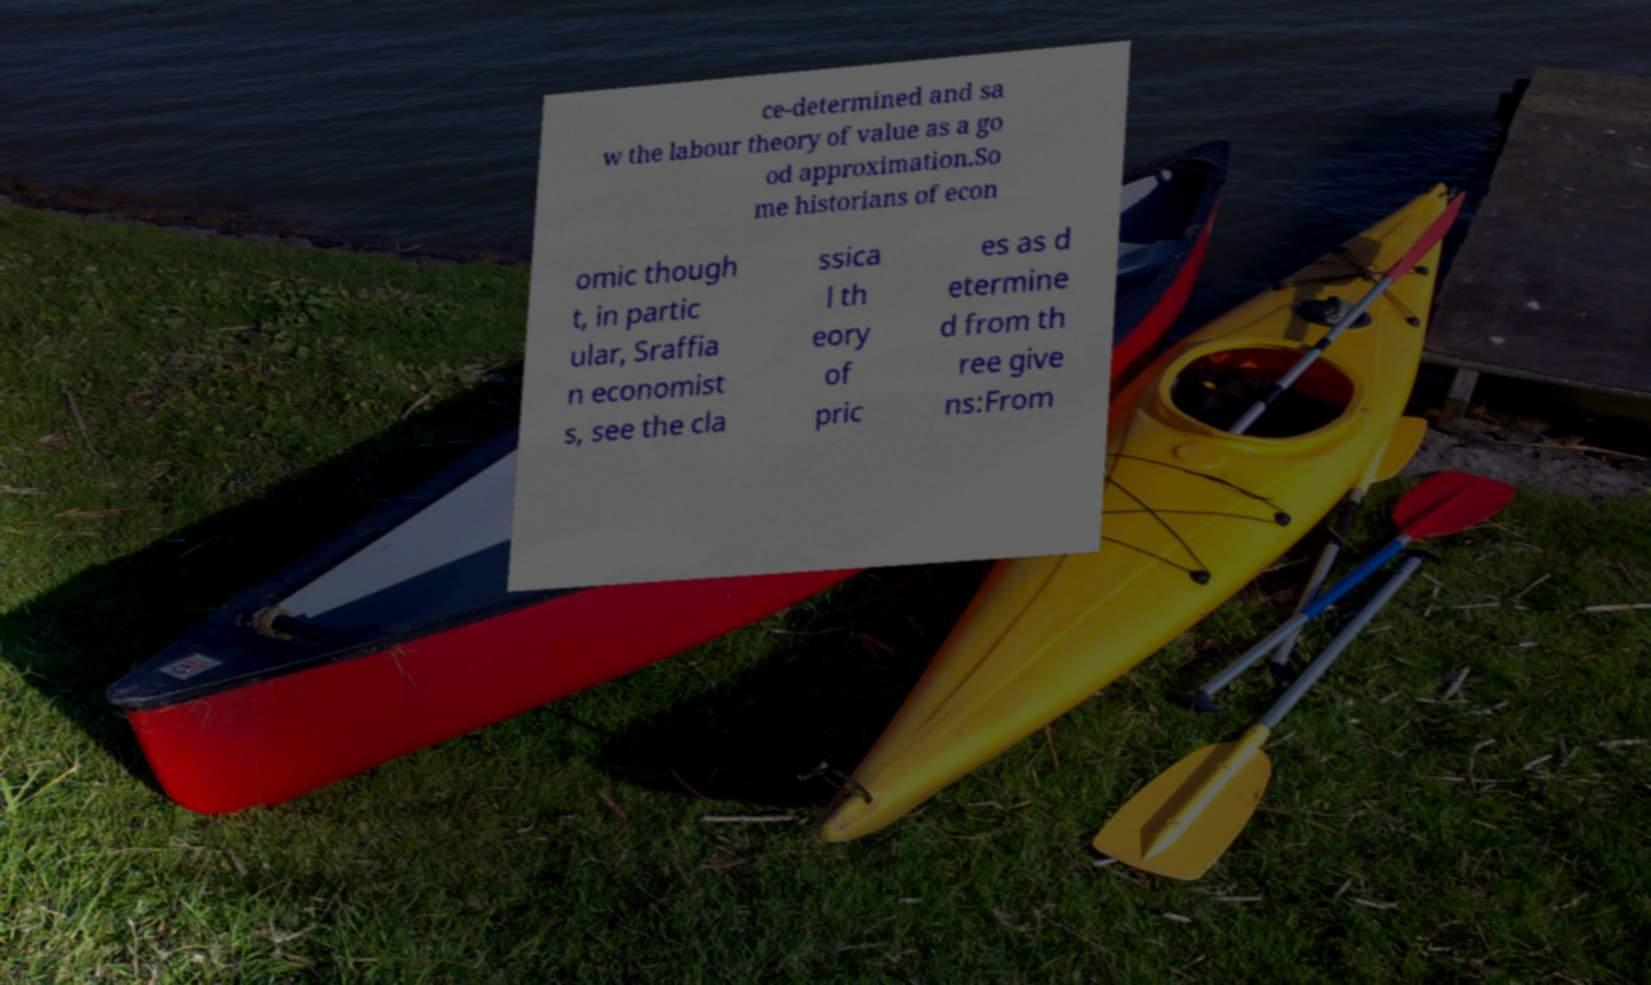Please read and relay the text visible in this image. What does it say? ce-determined and sa w the labour theory of value as a go od approximation.So me historians of econ omic though t, in partic ular, Sraffia n economist s, see the cla ssica l th eory of pric es as d etermine d from th ree give ns:From 